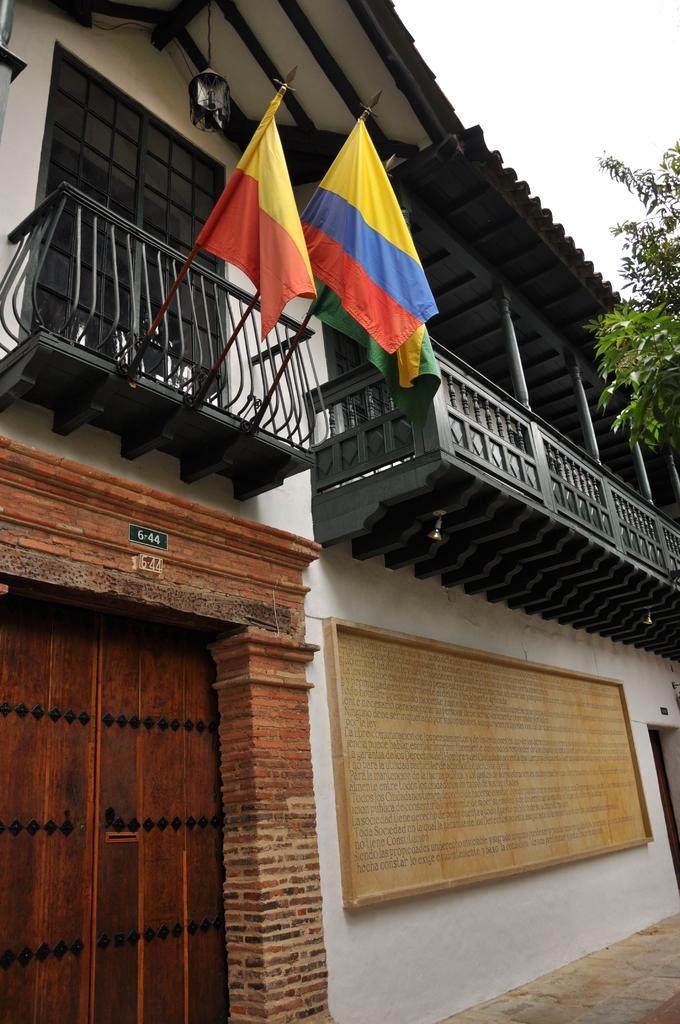What type of structure is depicted in the image? There is a two-floor building in the image. What is attached to a pole in the image? There is a flag on a pole in the image. How can someone enter the building in the image? There is a door to access the building in the image. What type of vegetation is near the building in the image? There is a tree beside the building in the image. What page of the book is the umbrella opened on in the image? There is no book or umbrella present in the image. How many yards of fabric were used to make the yard in the image? There is no yard or fabric mentioned in the image. 